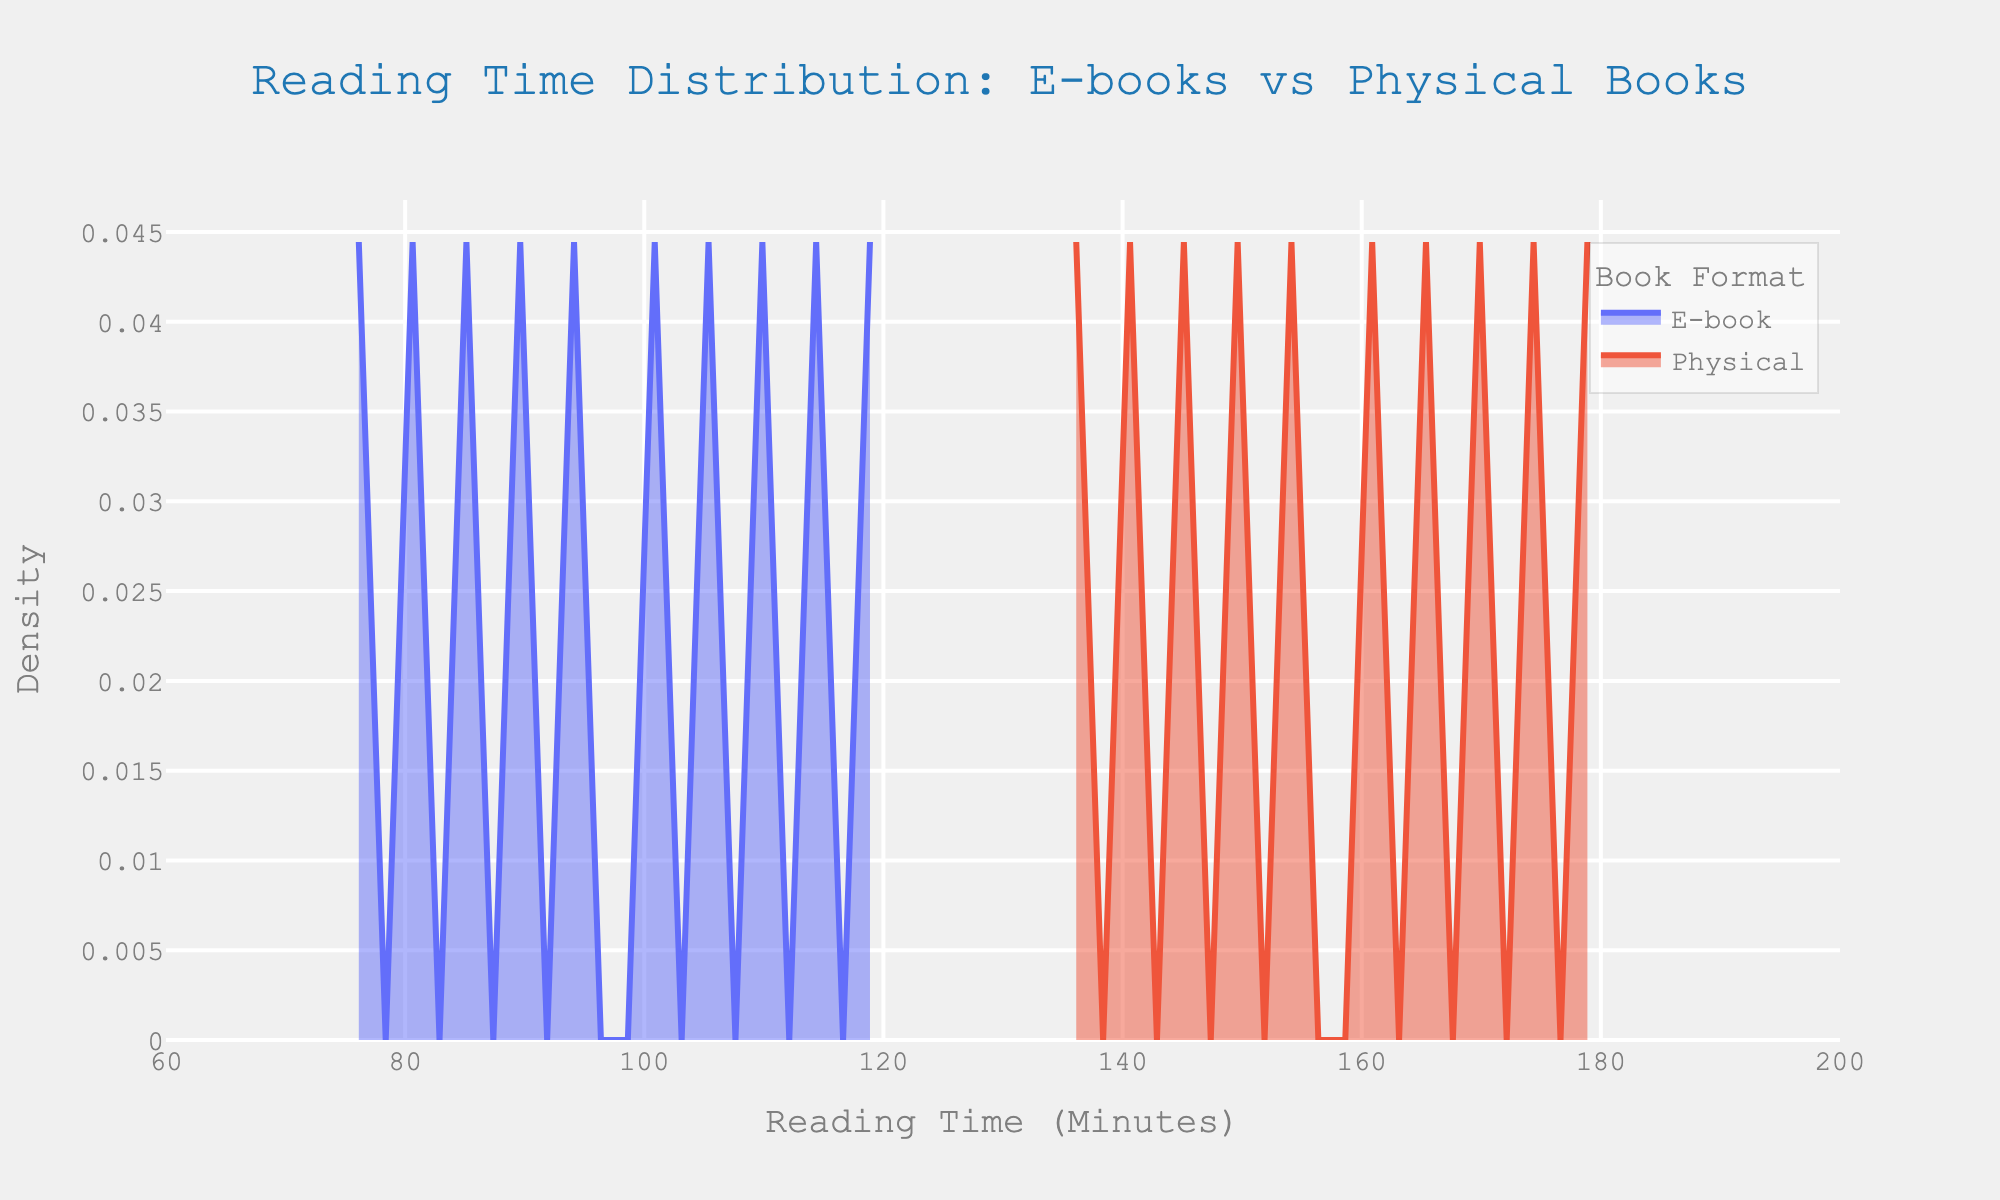What's the title of the plot? The title of the plot is displayed prominently at the top in a noticeable font.
Answer: Reading Time Distribution: E-books vs Physical Books What does the x-axis represent? The x-axis label is located below the axis, stating what the axis measures.
Answer: Reading Time (Minutes) What does the y-axis represent? The y-axis label is located to the left of the axis, stating what the axis measures.
Answer: Density Which book format has the higher peak density? By examining the peaks of the density curves, identify which one is higher.
Answer: E-book At approximately how many minutes does the peak density for physical books occur? The peak point for the physical books' density curve is where it reaches its highest value on the x-axis.
Answer: Around 160 minutes How does the reading time for e-books compare to physical books on average? Compare the average positions of the two density curves horizontally along the x-axis.
Answer: E-books have shorter reading times on average Which format shows more variability in reading time? Variability can be inferred from the width and spread of the density curves; a wider spread indicates more variability.
Answer: Physical books Is there any overlap between the reading times of e-books and physical books? Observe if the density curves of e-books and physical books intersect or overlap at any points along the x-axis.
Answer: Yes, there is overlap How would you describe the general trend of physical book reading times based on the plot? Observe the shape and spread of the density curve for physical books, considering where the most significant densities lie along the x-axis.
Answer: Physical books generally have longer reading times, with most density around 160-180 minutes Which book format has a smoother distribution curve? Examine the smoothness of the density lines for the two formats to determine which is smoother.
Answer: Physical books 